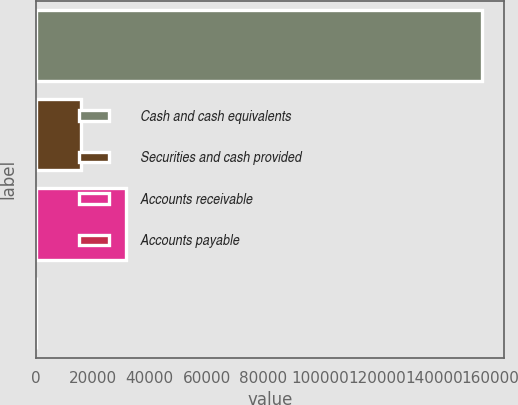Convert chart. <chart><loc_0><loc_0><loc_500><loc_500><bar_chart><fcel>Cash and cash equivalents<fcel>Securities and cash provided<fcel>Accounts receivable<fcel>Accounts payable<nl><fcel>156982<fcel>15775.6<fcel>31465.2<fcel>86<nl></chart> 